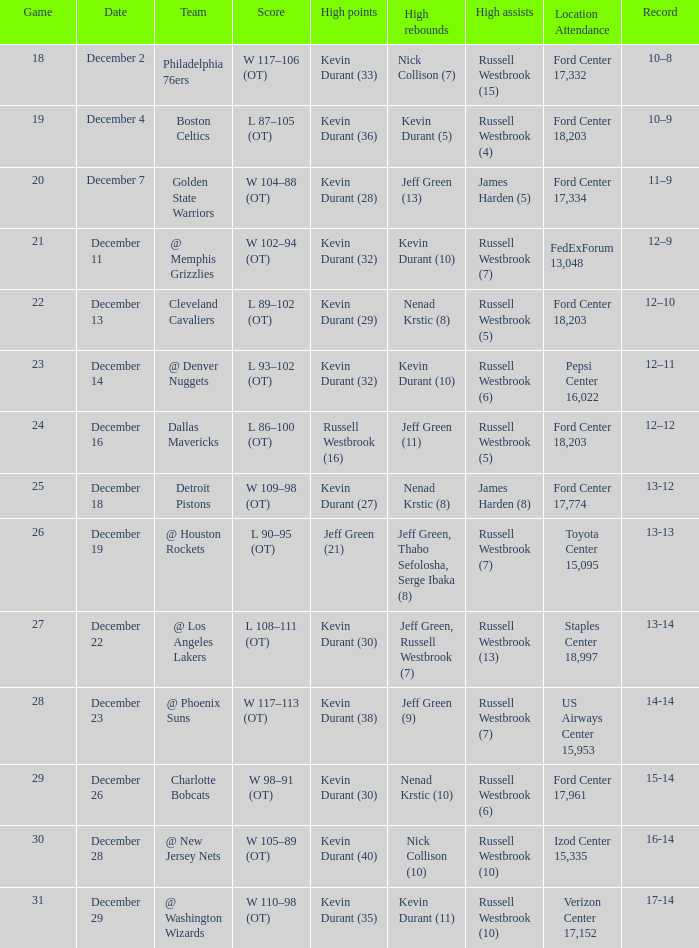Who has high points when verizon center 17,152 is location attendance? Kevin Durant (35). 